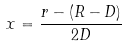Convert formula to latex. <formula><loc_0><loc_0><loc_500><loc_500>x = \frac { r - ( R - D ) } { 2 D }</formula> 